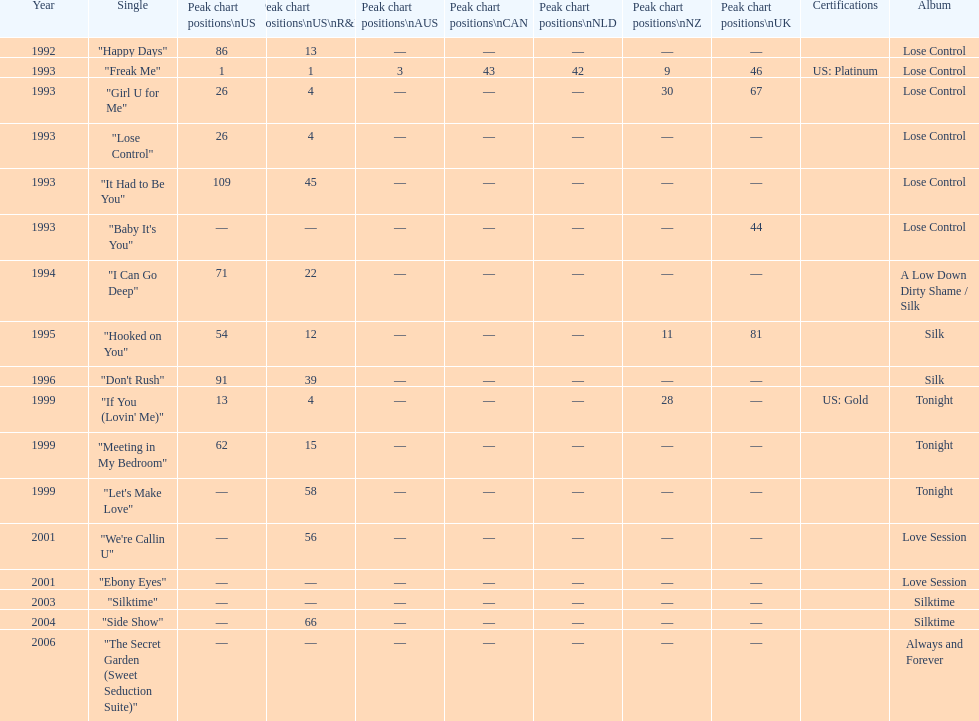Which phrase ranked higher on the us and us r&b charts: "i can go deep" or "don't rush"? "I Can Go Deep". Help me parse the entirety of this table. {'header': ['Year', 'Single', 'Peak chart positions\\nUS', 'Peak chart positions\\nUS\\nR&B', 'Peak chart positions\\nAUS', 'Peak chart positions\\nCAN', 'Peak chart positions\\nNLD', 'Peak chart positions\\nNZ', 'Peak chart positions\\nUK', 'Certifications', 'Album'], 'rows': [['1992', '"Happy Days"', '86', '13', '—', '—', '—', '—', '—', '', 'Lose Control'], ['1993', '"Freak Me"', '1', '1', '3', '43', '42', '9', '46', 'US: Platinum', 'Lose Control'], ['1993', '"Girl U for Me"', '26', '4', '—', '—', '—', '30', '67', '', 'Lose Control'], ['1993', '"Lose Control"', '26', '4', '—', '—', '—', '—', '—', '', 'Lose Control'], ['1993', '"It Had to Be You"', '109', '45', '—', '—', '—', '—', '—', '', 'Lose Control'], ['1993', '"Baby It\'s You"', '—', '—', '—', '—', '—', '—', '44', '', 'Lose Control'], ['1994', '"I Can Go Deep"', '71', '22', '—', '—', '—', '—', '—', '', 'A Low Down Dirty Shame / Silk'], ['1995', '"Hooked on You"', '54', '12', '—', '—', '—', '11', '81', '', 'Silk'], ['1996', '"Don\'t Rush"', '91', '39', '—', '—', '—', '—', '—', '', 'Silk'], ['1999', '"If You (Lovin\' Me)"', '13', '4', '—', '—', '—', '28', '—', 'US: Gold', 'Tonight'], ['1999', '"Meeting in My Bedroom"', '62', '15', '—', '—', '—', '—', '—', '', 'Tonight'], ['1999', '"Let\'s Make Love"', '—', '58', '—', '—', '—', '—', '—', '', 'Tonight'], ['2001', '"We\'re Callin U"', '—', '56', '—', '—', '—', '—', '—', '', 'Love Session'], ['2001', '"Ebony Eyes"', '—', '—', '—', '—', '—', '—', '—', '', 'Love Session'], ['2003', '"Silktime"', '—', '—', '—', '—', '—', '—', '—', '', 'Silktime'], ['2004', '"Side Show"', '—', '66', '—', '—', '—', '—', '—', '', 'Silktime'], ['2006', '"The Secret Garden (Sweet Seduction Suite)"', '—', '—', '—', '—', '—', '—', '—', '', 'Always and Forever']]} 